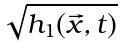Convert formula to latex. <formula><loc_0><loc_0><loc_500><loc_500>\sqrt { h _ { 1 } ( \vec { x } , t ) }</formula> 